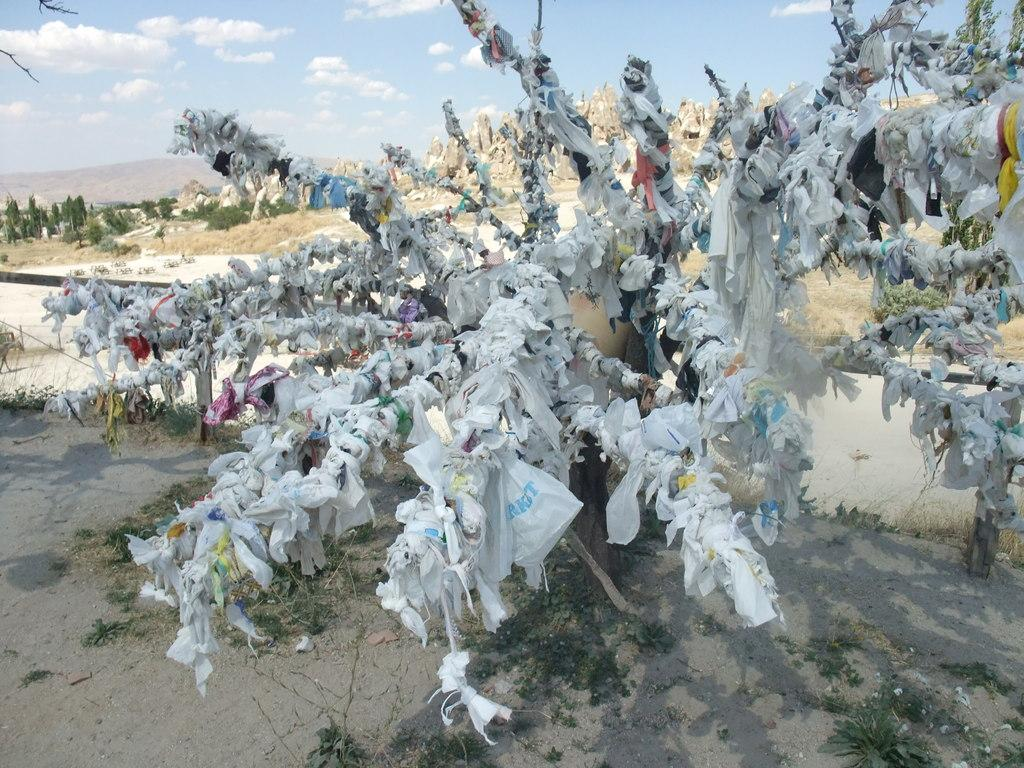What type of vegetation can be seen in the background of the image? There are trees in the background of the image. What objects are visible in the image that resemble long, thin rods? There are sticks visible in the image. What items are present in the image that are typically used to cover or protect something? Covers are present in the image. What is visible at the top of the image? The sky is visible at the top of the image. What type of grain is being used to write with in the image? There is no grain or writing instrument present in the image. What type of linen is draped over the furniture in the image? There is no linen or furniture present in the image. 